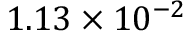Convert formula to latex. <formula><loc_0><loc_0><loc_500><loc_500>1 . 1 3 \times 1 0 ^ { - 2 }</formula> 